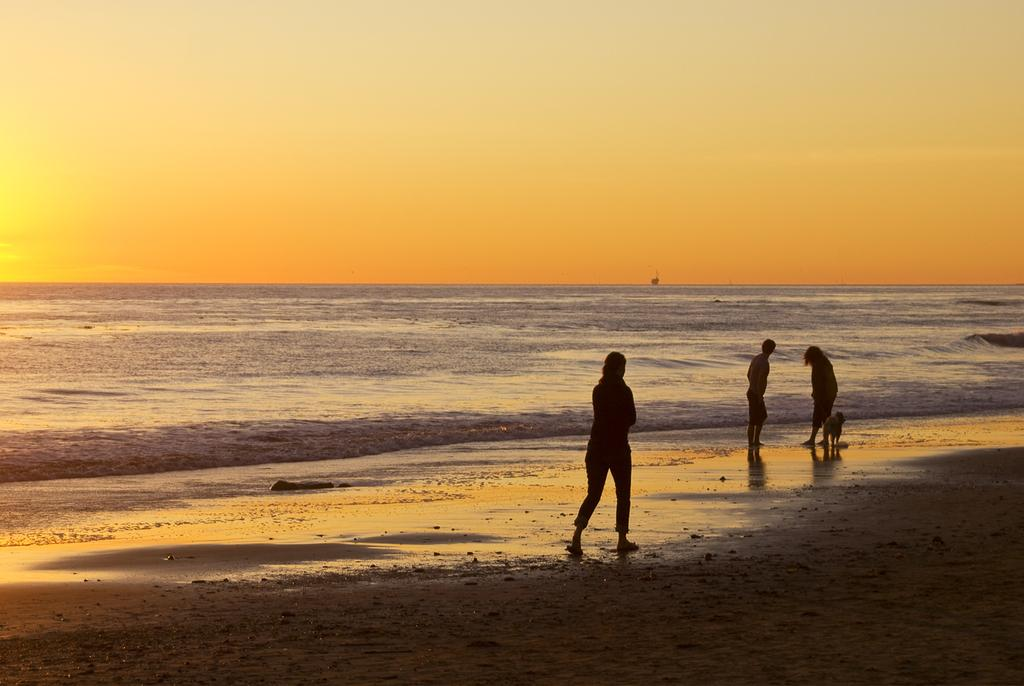How many people are in the image? There are three persons standing in the middle of the image. What else can be seen in the image besides the people? There is an animal and water visible behind the persons. What is visible at the top of the image? The sky is visible at the top of the image. What type of credit card is being used to purchase the straw in the image? There is no credit card or straw present in the image. What flavor of mint can be seen in the image? There is no mint present in the image. 